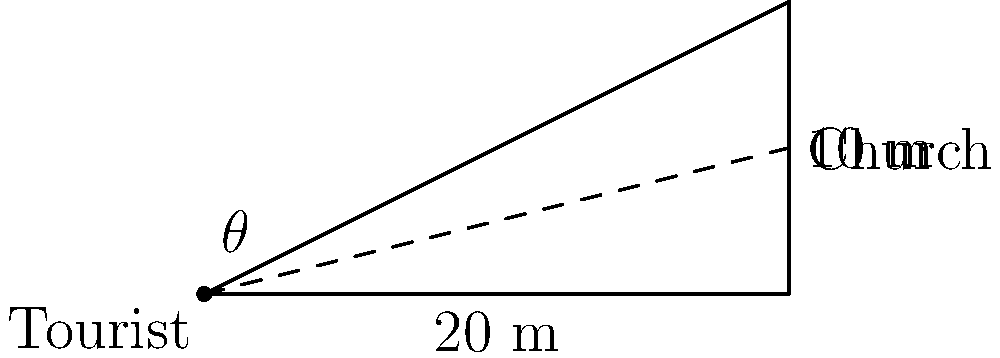A tourist wants to capture the entire façade of the Basilica Minore del Santo Niño, a historical church in Cebu City. The church is 20 meters wide and 10 meters tall. If the tourist stands directly in front of the church, what is the minimum distance they need to be from the church to capture the entire façade in a single photo, assuming their camera has a 60° field of view? Round your answer to the nearest meter. To solve this problem, we'll use trigonometry:

1) First, we need to find the angle $\theta$ that covers the entire height of the church from the tourist's position.

2) We can split the camera's field of view in half: 60° / 2 = 30°. This is the maximum angle $\theta$ can be for the entire church to fit in the frame.

3) We can use the tangent function to relate the height of the church to the distance from the church:

   $\tan(\theta) = \frac{\text{opposite}}{\text{adjacent}} = \frac{\text{height}}{\text{distance}}$

4) Rearranging this equation:

   $\text{distance} = \frac{\text{height}}{\tan(\theta)}$

5) Plugging in our values:

   $\text{distance} = \frac{10 \text{ m}}{\tan(30°)}$

6) Calculate:
   $\tan(30°) \approx 0.5774$
   $\text{distance} \approx \frac{10}{0.5774} \approx 17.32 \text{ m}$

7) Rounding to the nearest meter:

   $\text{distance} \approx 17 \text{ m}$

Therefore, the tourist needs to be at least 17 meters away from the church to capture its entire façade in one photo.
Answer: 17 meters 